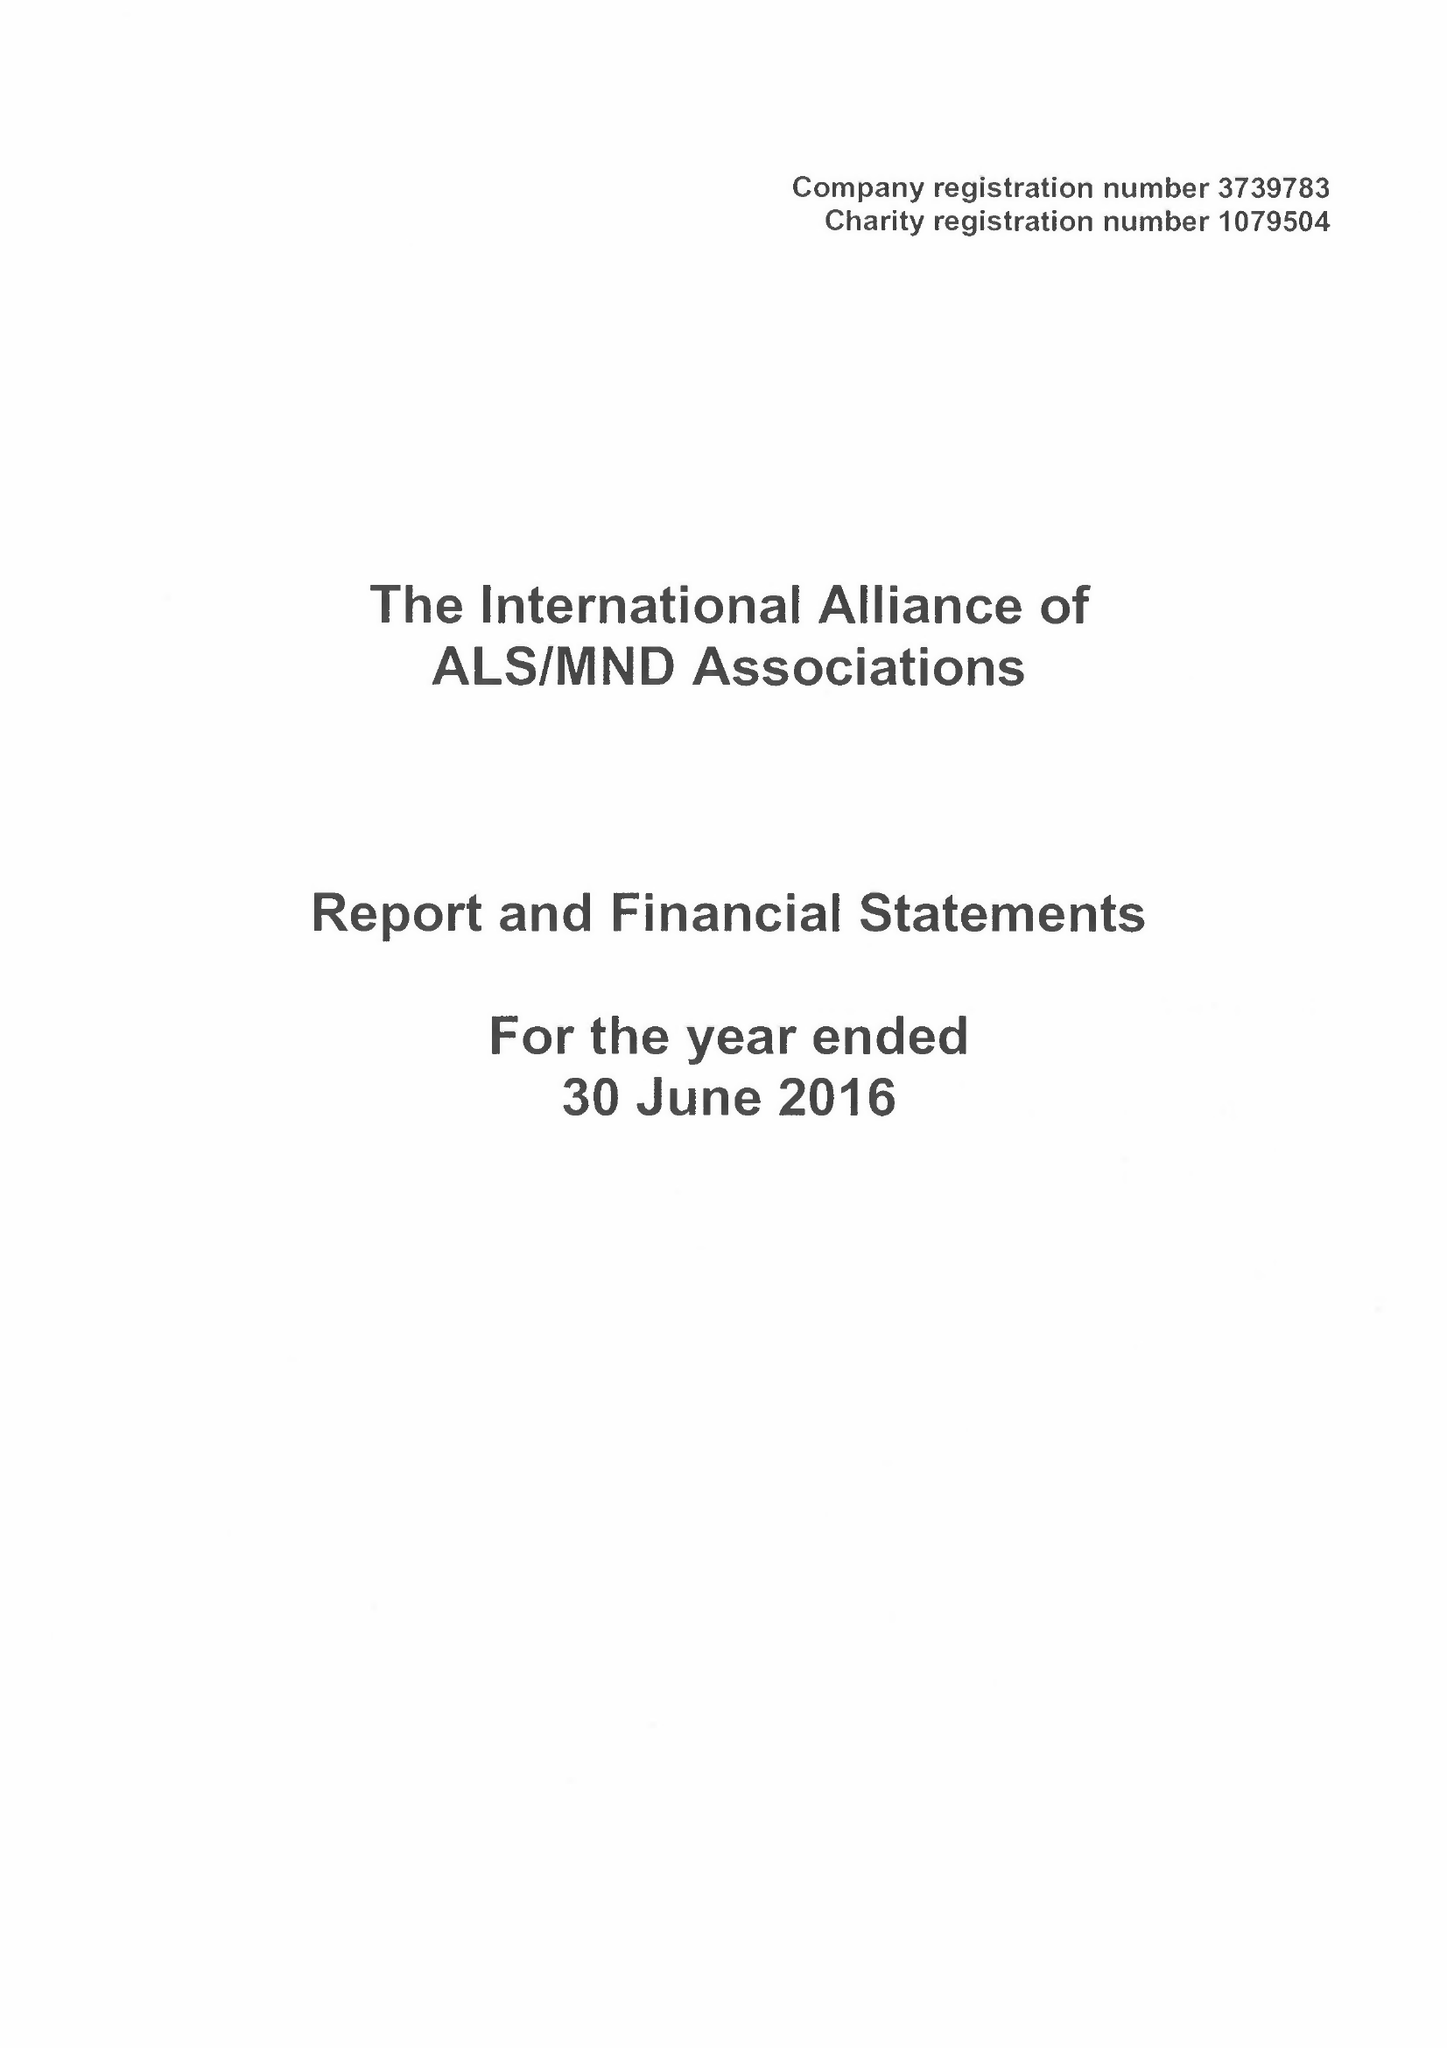What is the value for the address__postcode?
Answer the question using a single word or phrase. NN1 2BG 